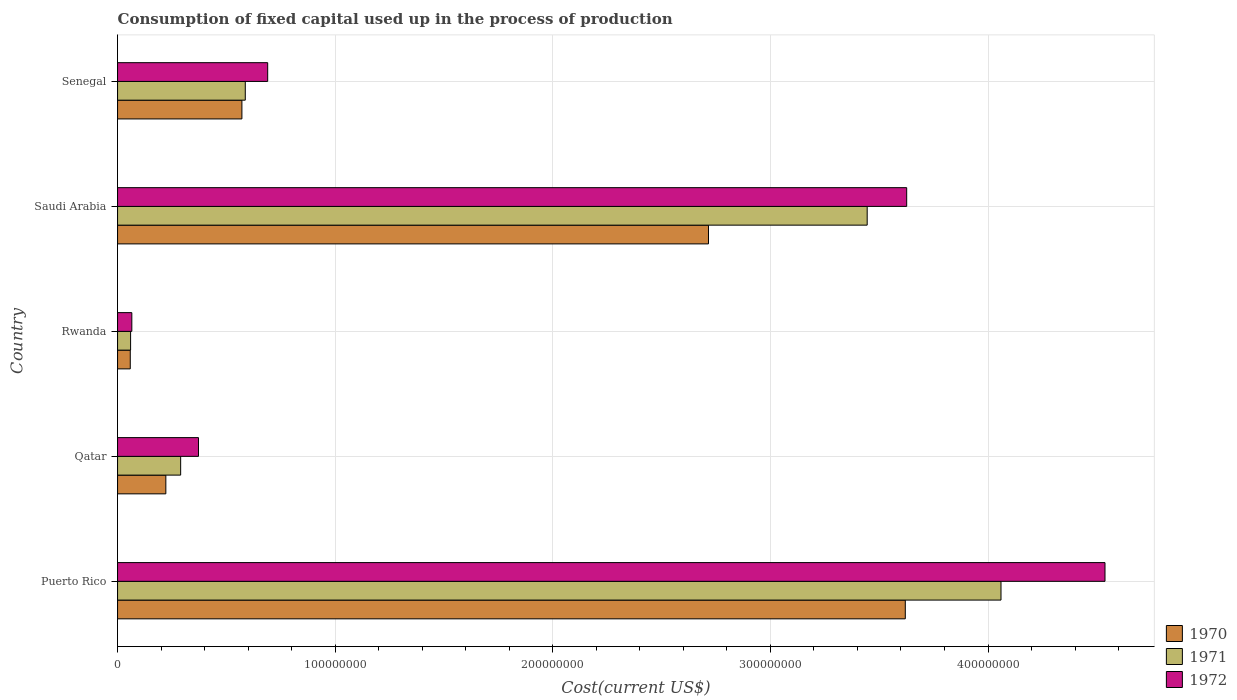Are the number of bars on each tick of the Y-axis equal?
Your answer should be compact. Yes. How many bars are there on the 2nd tick from the bottom?
Offer a very short reply. 3. What is the label of the 3rd group of bars from the top?
Offer a very short reply. Rwanda. In how many cases, is the number of bars for a given country not equal to the number of legend labels?
Keep it short and to the point. 0. What is the amount consumed in the process of production in 1972 in Saudi Arabia?
Offer a terse response. 3.63e+08. Across all countries, what is the maximum amount consumed in the process of production in 1971?
Provide a short and direct response. 4.06e+08. Across all countries, what is the minimum amount consumed in the process of production in 1971?
Give a very brief answer. 5.99e+06. In which country was the amount consumed in the process of production in 1972 maximum?
Your answer should be very brief. Puerto Rico. In which country was the amount consumed in the process of production in 1972 minimum?
Your response must be concise. Rwanda. What is the total amount consumed in the process of production in 1971 in the graph?
Your answer should be compact. 8.44e+08. What is the difference between the amount consumed in the process of production in 1970 in Qatar and that in Saudi Arabia?
Provide a succinct answer. -2.49e+08. What is the difference between the amount consumed in the process of production in 1971 in Saudi Arabia and the amount consumed in the process of production in 1970 in Qatar?
Provide a succinct answer. 3.22e+08. What is the average amount consumed in the process of production in 1970 per country?
Make the answer very short. 1.44e+08. What is the difference between the amount consumed in the process of production in 1971 and amount consumed in the process of production in 1970 in Senegal?
Your response must be concise. 1.55e+06. What is the ratio of the amount consumed in the process of production in 1970 in Rwanda to that in Senegal?
Offer a terse response. 0.1. Is the difference between the amount consumed in the process of production in 1971 in Rwanda and Saudi Arabia greater than the difference between the amount consumed in the process of production in 1970 in Rwanda and Saudi Arabia?
Give a very brief answer. No. What is the difference between the highest and the second highest amount consumed in the process of production in 1971?
Provide a short and direct response. 6.15e+07. What is the difference between the highest and the lowest amount consumed in the process of production in 1972?
Offer a terse response. 4.47e+08. In how many countries, is the amount consumed in the process of production in 1972 greater than the average amount consumed in the process of production in 1972 taken over all countries?
Give a very brief answer. 2. What does the 2nd bar from the top in Rwanda represents?
Keep it short and to the point. 1971. What does the 1st bar from the bottom in Rwanda represents?
Your answer should be compact. 1970. Is it the case that in every country, the sum of the amount consumed in the process of production in 1972 and amount consumed in the process of production in 1970 is greater than the amount consumed in the process of production in 1971?
Provide a succinct answer. Yes. How many bars are there?
Offer a terse response. 15. Does the graph contain any zero values?
Give a very brief answer. No. How are the legend labels stacked?
Offer a terse response. Vertical. What is the title of the graph?
Provide a short and direct response. Consumption of fixed capital used up in the process of production. What is the label or title of the X-axis?
Ensure brevity in your answer.  Cost(current US$). What is the label or title of the Y-axis?
Your answer should be compact. Country. What is the Cost(current US$) of 1970 in Puerto Rico?
Your answer should be compact. 3.62e+08. What is the Cost(current US$) of 1971 in Puerto Rico?
Give a very brief answer. 4.06e+08. What is the Cost(current US$) in 1972 in Puerto Rico?
Your answer should be very brief. 4.54e+08. What is the Cost(current US$) in 1970 in Qatar?
Your answer should be very brief. 2.22e+07. What is the Cost(current US$) of 1971 in Qatar?
Offer a very short reply. 2.90e+07. What is the Cost(current US$) of 1972 in Qatar?
Keep it short and to the point. 3.72e+07. What is the Cost(current US$) of 1970 in Rwanda?
Your answer should be very brief. 5.84e+06. What is the Cost(current US$) in 1971 in Rwanda?
Your answer should be very brief. 5.99e+06. What is the Cost(current US$) of 1972 in Rwanda?
Offer a very short reply. 6.56e+06. What is the Cost(current US$) of 1970 in Saudi Arabia?
Make the answer very short. 2.72e+08. What is the Cost(current US$) of 1971 in Saudi Arabia?
Your answer should be very brief. 3.44e+08. What is the Cost(current US$) of 1972 in Saudi Arabia?
Provide a succinct answer. 3.63e+08. What is the Cost(current US$) of 1970 in Senegal?
Your response must be concise. 5.71e+07. What is the Cost(current US$) in 1971 in Senegal?
Your response must be concise. 5.87e+07. What is the Cost(current US$) in 1972 in Senegal?
Ensure brevity in your answer.  6.90e+07. Across all countries, what is the maximum Cost(current US$) of 1970?
Your answer should be very brief. 3.62e+08. Across all countries, what is the maximum Cost(current US$) of 1971?
Your answer should be very brief. 4.06e+08. Across all countries, what is the maximum Cost(current US$) of 1972?
Ensure brevity in your answer.  4.54e+08. Across all countries, what is the minimum Cost(current US$) of 1970?
Give a very brief answer. 5.84e+06. Across all countries, what is the minimum Cost(current US$) in 1971?
Your response must be concise. 5.99e+06. Across all countries, what is the minimum Cost(current US$) of 1972?
Provide a succinct answer. 6.56e+06. What is the total Cost(current US$) in 1970 in the graph?
Provide a short and direct response. 7.19e+08. What is the total Cost(current US$) of 1971 in the graph?
Your answer should be very brief. 8.44e+08. What is the total Cost(current US$) in 1972 in the graph?
Give a very brief answer. 9.29e+08. What is the difference between the Cost(current US$) in 1970 in Puerto Rico and that in Qatar?
Give a very brief answer. 3.40e+08. What is the difference between the Cost(current US$) of 1971 in Puerto Rico and that in Qatar?
Your response must be concise. 3.77e+08. What is the difference between the Cost(current US$) in 1972 in Puerto Rico and that in Qatar?
Offer a terse response. 4.17e+08. What is the difference between the Cost(current US$) of 1970 in Puerto Rico and that in Rwanda?
Make the answer very short. 3.56e+08. What is the difference between the Cost(current US$) of 1971 in Puerto Rico and that in Rwanda?
Provide a succinct answer. 4.00e+08. What is the difference between the Cost(current US$) of 1972 in Puerto Rico and that in Rwanda?
Ensure brevity in your answer.  4.47e+08. What is the difference between the Cost(current US$) in 1970 in Puerto Rico and that in Saudi Arabia?
Offer a very short reply. 9.04e+07. What is the difference between the Cost(current US$) of 1971 in Puerto Rico and that in Saudi Arabia?
Provide a short and direct response. 6.15e+07. What is the difference between the Cost(current US$) in 1972 in Puerto Rico and that in Saudi Arabia?
Make the answer very short. 9.11e+07. What is the difference between the Cost(current US$) of 1970 in Puerto Rico and that in Senegal?
Ensure brevity in your answer.  3.05e+08. What is the difference between the Cost(current US$) of 1971 in Puerto Rico and that in Senegal?
Provide a short and direct response. 3.47e+08. What is the difference between the Cost(current US$) in 1972 in Puerto Rico and that in Senegal?
Your answer should be compact. 3.85e+08. What is the difference between the Cost(current US$) in 1970 in Qatar and that in Rwanda?
Your answer should be very brief. 1.63e+07. What is the difference between the Cost(current US$) of 1971 in Qatar and that in Rwanda?
Make the answer very short. 2.30e+07. What is the difference between the Cost(current US$) in 1972 in Qatar and that in Rwanda?
Your answer should be very brief. 3.06e+07. What is the difference between the Cost(current US$) of 1970 in Qatar and that in Saudi Arabia?
Ensure brevity in your answer.  -2.49e+08. What is the difference between the Cost(current US$) in 1971 in Qatar and that in Saudi Arabia?
Keep it short and to the point. -3.15e+08. What is the difference between the Cost(current US$) in 1972 in Qatar and that in Saudi Arabia?
Your answer should be very brief. -3.25e+08. What is the difference between the Cost(current US$) of 1970 in Qatar and that in Senegal?
Offer a terse response. -3.50e+07. What is the difference between the Cost(current US$) of 1971 in Qatar and that in Senegal?
Make the answer very short. -2.97e+07. What is the difference between the Cost(current US$) of 1972 in Qatar and that in Senegal?
Offer a terse response. -3.18e+07. What is the difference between the Cost(current US$) in 1970 in Rwanda and that in Saudi Arabia?
Your answer should be compact. -2.66e+08. What is the difference between the Cost(current US$) in 1971 in Rwanda and that in Saudi Arabia?
Keep it short and to the point. -3.38e+08. What is the difference between the Cost(current US$) in 1972 in Rwanda and that in Saudi Arabia?
Provide a short and direct response. -3.56e+08. What is the difference between the Cost(current US$) of 1970 in Rwanda and that in Senegal?
Your answer should be very brief. -5.13e+07. What is the difference between the Cost(current US$) in 1971 in Rwanda and that in Senegal?
Give a very brief answer. -5.27e+07. What is the difference between the Cost(current US$) in 1972 in Rwanda and that in Senegal?
Your answer should be compact. -6.24e+07. What is the difference between the Cost(current US$) of 1970 in Saudi Arabia and that in Senegal?
Your answer should be compact. 2.14e+08. What is the difference between the Cost(current US$) of 1971 in Saudi Arabia and that in Senegal?
Your answer should be very brief. 2.86e+08. What is the difference between the Cost(current US$) of 1972 in Saudi Arabia and that in Senegal?
Offer a very short reply. 2.94e+08. What is the difference between the Cost(current US$) in 1970 in Puerto Rico and the Cost(current US$) in 1971 in Qatar?
Provide a short and direct response. 3.33e+08. What is the difference between the Cost(current US$) in 1970 in Puerto Rico and the Cost(current US$) in 1972 in Qatar?
Your answer should be very brief. 3.25e+08. What is the difference between the Cost(current US$) in 1971 in Puerto Rico and the Cost(current US$) in 1972 in Qatar?
Your answer should be compact. 3.69e+08. What is the difference between the Cost(current US$) in 1970 in Puerto Rico and the Cost(current US$) in 1971 in Rwanda?
Keep it short and to the point. 3.56e+08. What is the difference between the Cost(current US$) in 1970 in Puerto Rico and the Cost(current US$) in 1972 in Rwanda?
Your response must be concise. 3.55e+08. What is the difference between the Cost(current US$) in 1971 in Puerto Rico and the Cost(current US$) in 1972 in Rwanda?
Provide a short and direct response. 3.99e+08. What is the difference between the Cost(current US$) of 1970 in Puerto Rico and the Cost(current US$) of 1971 in Saudi Arabia?
Offer a very short reply. 1.75e+07. What is the difference between the Cost(current US$) in 1970 in Puerto Rico and the Cost(current US$) in 1972 in Saudi Arabia?
Your answer should be very brief. -6.36e+05. What is the difference between the Cost(current US$) in 1971 in Puerto Rico and the Cost(current US$) in 1972 in Saudi Arabia?
Offer a terse response. 4.33e+07. What is the difference between the Cost(current US$) of 1970 in Puerto Rico and the Cost(current US$) of 1971 in Senegal?
Keep it short and to the point. 3.03e+08. What is the difference between the Cost(current US$) of 1970 in Puerto Rico and the Cost(current US$) of 1972 in Senegal?
Make the answer very short. 2.93e+08. What is the difference between the Cost(current US$) in 1971 in Puerto Rico and the Cost(current US$) in 1972 in Senegal?
Your response must be concise. 3.37e+08. What is the difference between the Cost(current US$) of 1970 in Qatar and the Cost(current US$) of 1971 in Rwanda?
Your answer should be very brief. 1.62e+07. What is the difference between the Cost(current US$) of 1970 in Qatar and the Cost(current US$) of 1972 in Rwanda?
Ensure brevity in your answer.  1.56e+07. What is the difference between the Cost(current US$) in 1971 in Qatar and the Cost(current US$) in 1972 in Rwanda?
Your answer should be compact. 2.24e+07. What is the difference between the Cost(current US$) in 1970 in Qatar and the Cost(current US$) in 1971 in Saudi Arabia?
Keep it short and to the point. -3.22e+08. What is the difference between the Cost(current US$) in 1970 in Qatar and the Cost(current US$) in 1972 in Saudi Arabia?
Give a very brief answer. -3.40e+08. What is the difference between the Cost(current US$) in 1971 in Qatar and the Cost(current US$) in 1972 in Saudi Arabia?
Your response must be concise. -3.34e+08. What is the difference between the Cost(current US$) in 1970 in Qatar and the Cost(current US$) in 1971 in Senegal?
Your answer should be very brief. -3.65e+07. What is the difference between the Cost(current US$) in 1970 in Qatar and the Cost(current US$) in 1972 in Senegal?
Offer a very short reply. -4.68e+07. What is the difference between the Cost(current US$) of 1971 in Qatar and the Cost(current US$) of 1972 in Senegal?
Your response must be concise. -4.00e+07. What is the difference between the Cost(current US$) of 1970 in Rwanda and the Cost(current US$) of 1971 in Saudi Arabia?
Ensure brevity in your answer.  -3.39e+08. What is the difference between the Cost(current US$) of 1970 in Rwanda and the Cost(current US$) of 1972 in Saudi Arabia?
Ensure brevity in your answer.  -3.57e+08. What is the difference between the Cost(current US$) of 1971 in Rwanda and the Cost(current US$) of 1972 in Saudi Arabia?
Make the answer very short. -3.57e+08. What is the difference between the Cost(current US$) in 1970 in Rwanda and the Cost(current US$) in 1971 in Senegal?
Keep it short and to the point. -5.29e+07. What is the difference between the Cost(current US$) of 1970 in Rwanda and the Cost(current US$) of 1972 in Senegal?
Your answer should be very brief. -6.31e+07. What is the difference between the Cost(current US$) in 1971 in Rwanda and the Cost(current US$) in 1972 in Senegal?
Your response must be concise. -6.30e+07. What is the difference between the Cost(current US$) of 1970 in Saudi Arabia and the Cost(current US$) of 1971 in Senegal?
Give a very brief answer. 2.13e+08. What is the difference between the Cost(current US$) in 1970 in Saudi Arabia and the Cost(current US$) in 1972 in Senegal?
Provide a succinct answer. 2.03e+08. What is the difference between the Cost(current US$) of 1971 in Saudi Arabia and the Cost(current US$) of 1972 in Senegal?
Your response must be concise. 2.75e+08. What is the average Cost(current US$) of 1970 per country?
Ensure brevity in your answer.  1.44e+08. What is the average Cost(current US$) of 1971 per country?
Offer a very short reply. 1.69e+08. What is the average Cost(current US$) of 1972 per country?
Offer a very short reply. 1.86e+08. What is the difference between the Cost(current US$) of 1970 and Cost(current US$) of 1971 in Puerto Rico?
Your answer should be compact. -4.40e+07. What is the difference between the Cost(current US$) in 1970 and Cost(current US$) in 1972 in Puerto Rico?
Give a very brief answer. -9.18e+07. What is the difference between the Cost(current US$) in 1971 and Cost(current US$) in 1972 in Puerto Rico?
Your answer should be compact. -4.78e+07. What is the difference between the Cost(current US$) in 1970 and Cost(current US$) in 1971 in Qatar?
Your answer should be compact. -6.81e+06. What is the difference between the Cost(current US$) in 1970 and Cost(current US$) in 1972 in Qatar?
Make the answer very short. -1.50e+07. What is the difference between the Cost(current US$) in 1971 and Cost(current US$) in 1972 in Qatar?
Offer a very short reply. -8.20e+06. What is the difference between the Cost(current US$) of 1970 and Cost(current US$) of 1971 in Rwanda?
Keep it short and to the point. -1.47e+05. What is the difference between the Cost(current US$) of 1970 and Cost(current US$) of 1972 in Rwanda?
Offer a very short reply. -7.15e+05. What is the difference between the Cost(current US$) of 1971 and Cost(current US$) of 1972 in Rwanda?
Keep it short and to the point. -5.68e+05. What is the difference between the Cost(current US$) of 1970 and Cost(current US$) of 1971 in Saudi Arabia?
Provide a short and direct response. -7.29e+07. What is the difference between the Cost(current US$) in 1970 and Cost(current US$) in 1972 in Saudi Arabia?
Ensure brevity in your answer.  -9.11e+07. What is the difference between the Cost(current US$) in 1971 and Cost(current US$) in 1972 in Saudi Arabia?
Make the answer very short. -1.81e+07. What is the difference between the Cost(current US$) in 1970 and Cost(current US$) in 1971 in Senegal?
Give a very brief answer. -1.55e+06. What is the difference between the Cost(current US$) of 1970 and Cost(current US$) of 1972 in Senegal?
Your response must be concise. -1.18e+07. What is the difference between the Cost(current US$) of 1971 and Cost(current US$) of 1972 in Senegal?
Your answer should be very brief. -1.03e+07. What is the ratio of the Cost(current US$) in 1970 in Puerto Rico to that in Qatar?
Keep it short and to the point. 16.31. What is the ratio of the Cost(current US$) in 1971 in Puerto Rico to that in Qatar?
Provide a short and direct response. 14. What is the ratio of the Cost(current US$) of 1972 in Puerto Rico to that in Qatar?
Ensure brevity in your answer.  12.2. What is the ratio of the Cost(current US$) in 1970 in Puerto Rico to that in Rwanda?
Your response must be concise. 61.97. What is the ratio of the Cost(current US$) of 1971 in Puerto Rico to that in Rwanda?
Your answer should be very brief. 67.79. What is the ratio of the Cost(current US$) in 1972 in Puerto Rico to that in Rwanda?
Provide a succinct answer. 69.21. What is the ratio of the Cost(current US$) in 1970 in Puerto Rico to that in Saudi Arabia?
Ensure brevity in your answer.  1.33. What is the ratio of the Cost(current US$) in 1971 in Puerto Rico to that in Saudi Arabia?
Give a very brief answer. 1.18. What is the ratio of the Cost(current US$) in 1972 in Puerto Rico to that in Saudi Arabia?
Offer a very short reply. 1.25. What is the ratio of the Cost(current US$) in 1970 in Puerto Rico to that in Senegal?
Ensure brevity in your answer.  6.34. What is the ratio of the Cost(current US$) of 1971 in Puerto Rico to that in Senegal?
Provide a short and direct response. 6.92. What is the ratio of the Cost(current US$) in 1972 in Puerto Rico to that in Senegal?
Your answer should be very brief. 6.58. What is the ratio of the Cost(current US$) of 1970 in Qatar to that in Rwanda?
Provide a short and direct response. 3.8. What is the ratio of the Cost(current US$) of 1971 in Qatar to that in Rwanda?
Offer a very short reply. 4.84. What is the ratio of the Cost(current US$) of 1972 in Qatar to that in Rwanda?
Give a very brief answer. 5.67. What is the ratio of the Cost(current US$) of 1970 in Qatar to that in Saudi Arabia?
Offer a very short reply. 0.08. What is the ratio of the Cost(current US$) in 1971 in Qatar to that in Saudi Arabia?
Offer a very short reply. 0.08. What is the ratio of the Cost(current US$) in 1972 in Qatar to that in Saudi Arabia?
Provide a succinct answer. 0.1. What is the ratio of the Cost(current US$) of 1970 in Qatar to that in Senegal?
Make the answer very short. 0.39. What is the ratio of the Cost(current US$) of 1971 in Qatar to that in Senegal?
Provide a short and direct response. 0.49. What is the ratio of the Cost(current US$) in 1972 in Qatar to that in Senegal?
Keep it short and to the point. 0.54. What is the ratio of the Cost(current US$) of 1970 in Rwanda to that in Saudi Arabia?
Make the answer very short. 0.02. What is the ratio of the Cost(current US$) of 1971 in Rwanda to that in Saudi Arabia?
Your answer should be very brief. 0.02. What is the ratio of the Cost(current US$) in 1972 in Rwanda to that in Saudi Arabia?
Offer a very short reply. 0.02. What is the ratio of the Cost(current US$) in 1970 in Rwanda to that in Senegal?
Ensure brevity in your answer.  0.1. What is the ratio of the Cost(current US$) of 1971 in Rwanda to that in Senegal?
Keep it short and to the point. 0.1. What is the ratio of the Cost(current US$) of 1972 in Rwanda to that in Senegal?
Offer a very short reply. 0.1. What is the ratio of the Cost(current US$) of 1970 in Saudi Arabia to that in Senegal?
Your answer should be compact. 4.75. What is the ratio of the Cost(current US$) of 1971 in Saudi Arabia to that in Senegal?
Your answer should be very brief. 5.87. What is the ratio of the Cost(current US$) in 1972 in Saudi Arabia to that in Senegal?
Your answer should be compact. 5.26. What is the difference between the highest and the second highest Cost(current US$) of 1970?
Keep it short and to the point. 9.04e+07. What is the difference between the highest and the second highest Cost(current US$) in 1971?
Your answer should be very brief. 6.15e+07. What is the difference between the highest and the second highest Cost(current US$) of 1972?
Give a very brief answer. 9.11e+07. What is the difference between the highest and the lowest Cost(current US$) in 1970?
Make the answer very short. 3.56e+08. What is the difference between the highest and the lowest Cost(current US$) of 1971?
Offer a terse response. 4.00e+08. What is the difference between the highest and the lowest Cost(current US$) in 1972?
Offer a very short reply. 4.47e+08. 